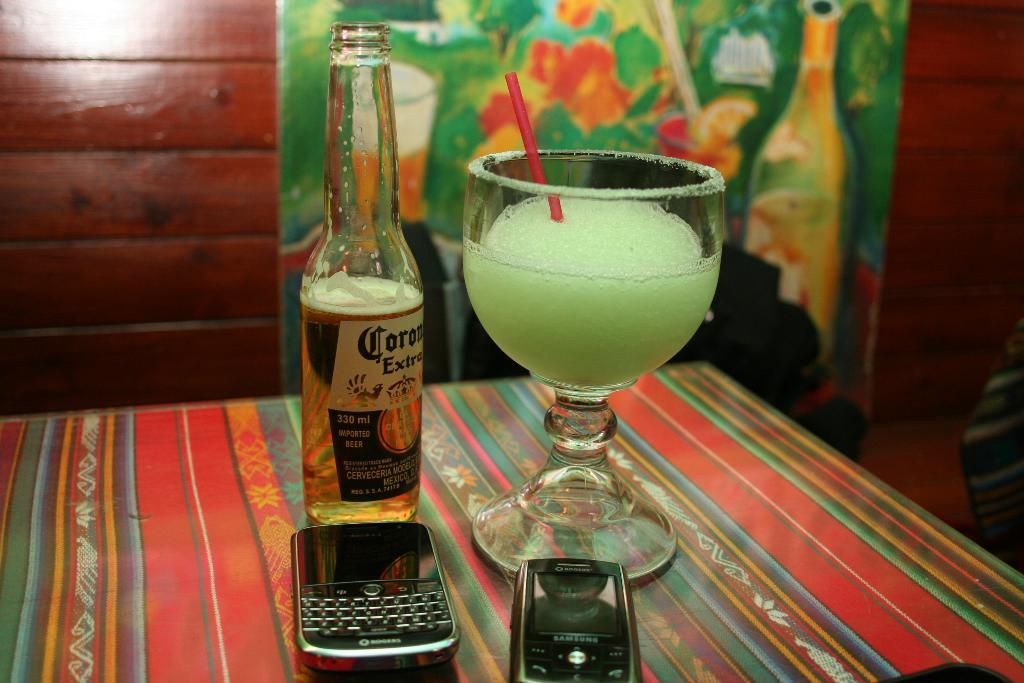<image>
Write a terse but informative summary of the picture. A half full corona bottle is next to two pones and a margarita. 